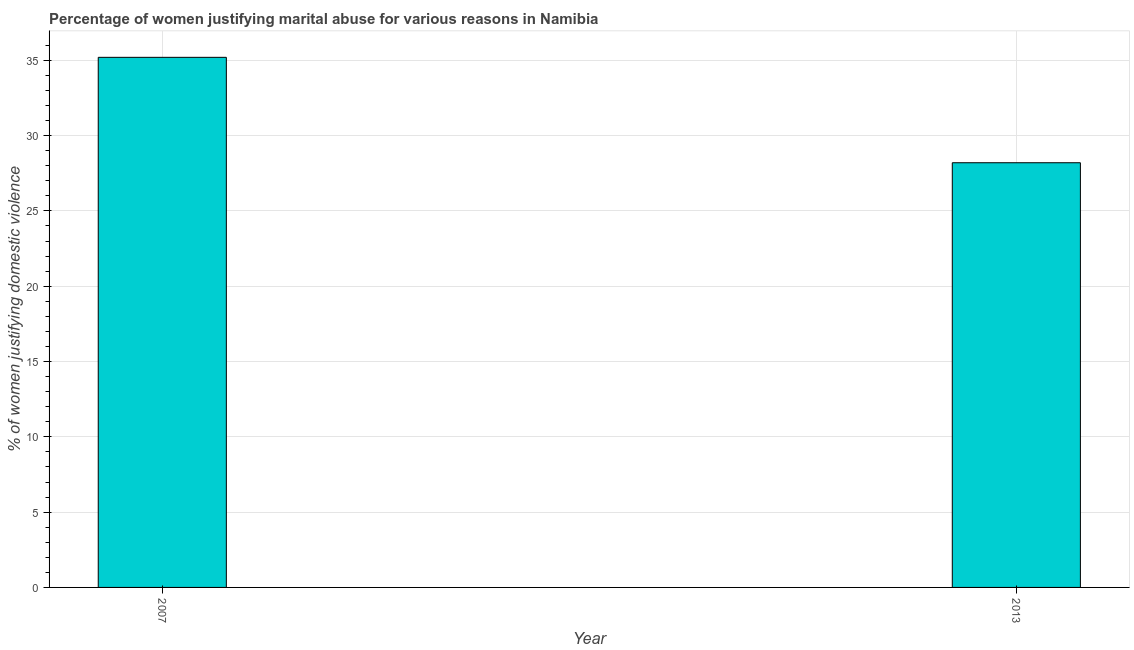What is the title of the graph?
Ensure brevity in your answer.  Percentage of women justifying marital abuse for various reasons in Namibia. What is the label or title of the X-axis?
Make the answer very short. Year. What is the label or title of the Y-axis?
Give a very brief answer. % of women justifying domestic violence. What is the percentage of women justifying marital abuse in 2013?
Provide a short and direct response. 28.2. Across all years, what is the maximum percentage of women justifying marital abuse?
Your response must be concise. 35.2. Across all years, what is the minimum percentage of women justifying marital abuse?
Offer a terse response. 28.2. In which year was the percentage of women justifying marital abuse minimum?
Keep it short and to the point. 2013. What is the sum of the percentage of women justifying marital abuse?
Provide a short and direct response. 63.4. What is the average percentage of women justifying marital abuse per year?
Your response must be concise. 31.7. What is the median percentage of women justifying marital abuse?
Provide a short and direct response. 31.7. In how many years, is the percentage of women justifying marital abuse greater than 31 %?
Make the answer very short. 1. Do a majority of the years between 2007 and 2013 (inclusive) have percentage of women justifying marital abuse greater than 5 %?
Your response must be concise. Yes. What is the ratio of the percentage of women justifying marital abuse in 2007 to that in 2013?
Your answer should be compact. 1.25. Is the percentage of women justifying marital abuse in 2007 less than that in 2013?
Make the answer very short. No. Are all the bars in the graph horizontal?
Provide a short and direct response. No. How many years are there in the graph?
Ensure brevity in your answer.  2. Are the values on the major ticks of Y-axis written in scientific E-notation?
Make the answer very short. No. What is the % of women justifying domestic violence of 2007?
Your answer should be compact. 35.2. What is the % of women justifying domestic violence of 2013?
Make the answer very short. 28.2. What is the ratio of the % of women justifying domestic violence in 2007 to that in 2013?
Provide a short and direct response. 1.25. 